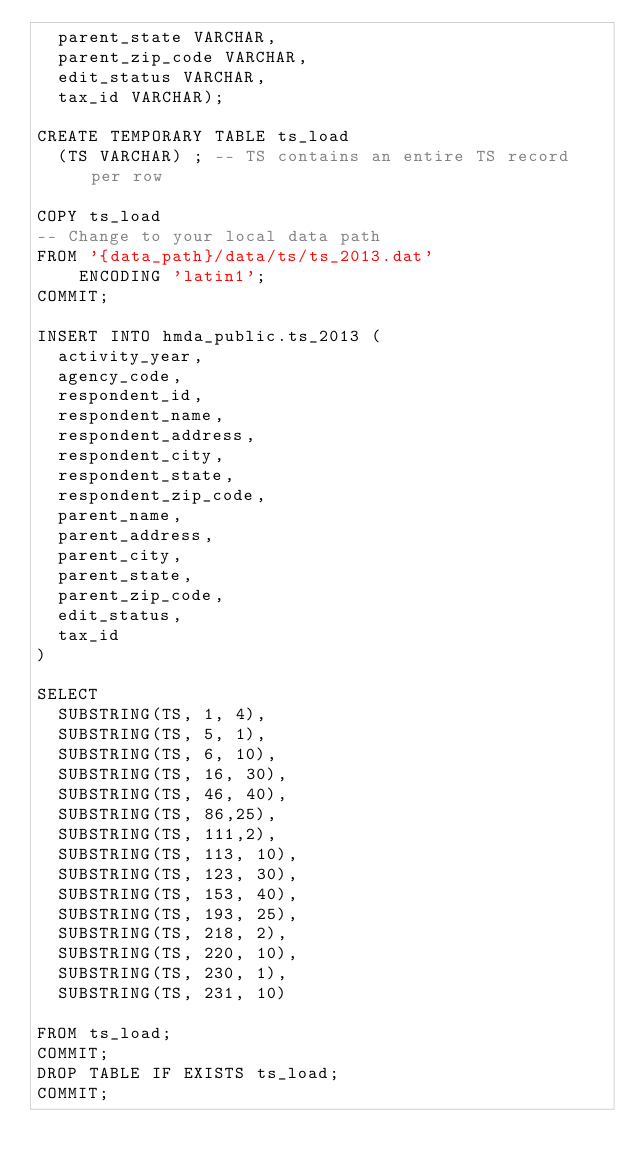Convert code to text. <code><loc_0><loc_0><loc_500><loc_500><_SQL_>	parent_state VARCHAR,
	parent_zip_code VARCHAR,
	edit_status VARCHAR,
	tax_id VARCHAR);

CREATE TEMPORARY TABLE ts_load 
  (TS VARCHAR) ; -- TS contains an entire TS record per row

COPY ts_load 
-- Change to your local data path
FROM '{data_path}/data/ts/ts_2013.dat' 
    ENCODING 'latin1';
COMMIT;

INSERT INTO hmda_public.ts_2013 (
	activity_year,
	agency_code,
	respondent_id,
	respondent_name,
	respondent_address,
	respondent_city,
	respondent_state,
	respondent_zip_code,
	parent_name,
	parent_address,
	parent_city,
	parent_state,
	parent_zip_code,
	edit_status,
	tax_id
)

SELECT 
	SUBSTRING(TS, 1, 4),
	SUBSTRING(TS, 5, 1),
	SUBSTRING(TS, 6, 10),
	SUBSTRING(TS, 16, 30),
	SUBSTRING(TS, 46, 40),
	SUBSTRING(TS, 86,25),
	SUBSTRING(TS, 111,2),
	SUBSTRING(TS, 113, 10),
	SUBSTRING(TS, 123, 30),
	SUBSTRING(TS, 153, 40),
	SUBSTRING(TS, 193, 25),
	SUBSTRING(TS, 218, 2),
	SUBSTRING(TS, 220, 10),
	SUBSTRING(TS, 230, 1),
	SUBSTRING(TS, 231, 10)

FROM ts_load;
COMMIT;
DROP TABLE IF EXISTS ts_load; 
COMMIT;
</code> 